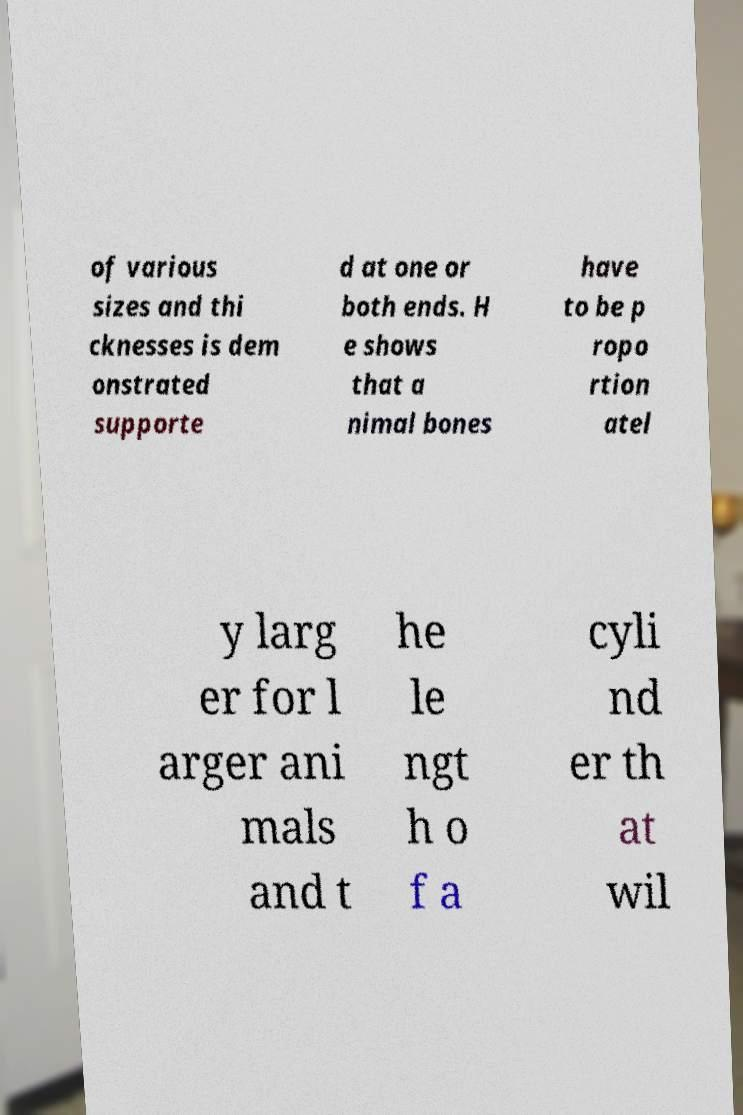Please read and relay the text visible in this image. What does it say? of various sizes and thi cknesses is dem onstrated supporte d at one or both ends. H e shows that a nimal bones have to be p ropo rtion atel y larg er for l arger ani mals and t he le ngt h o f a cyli nd er th at wil 